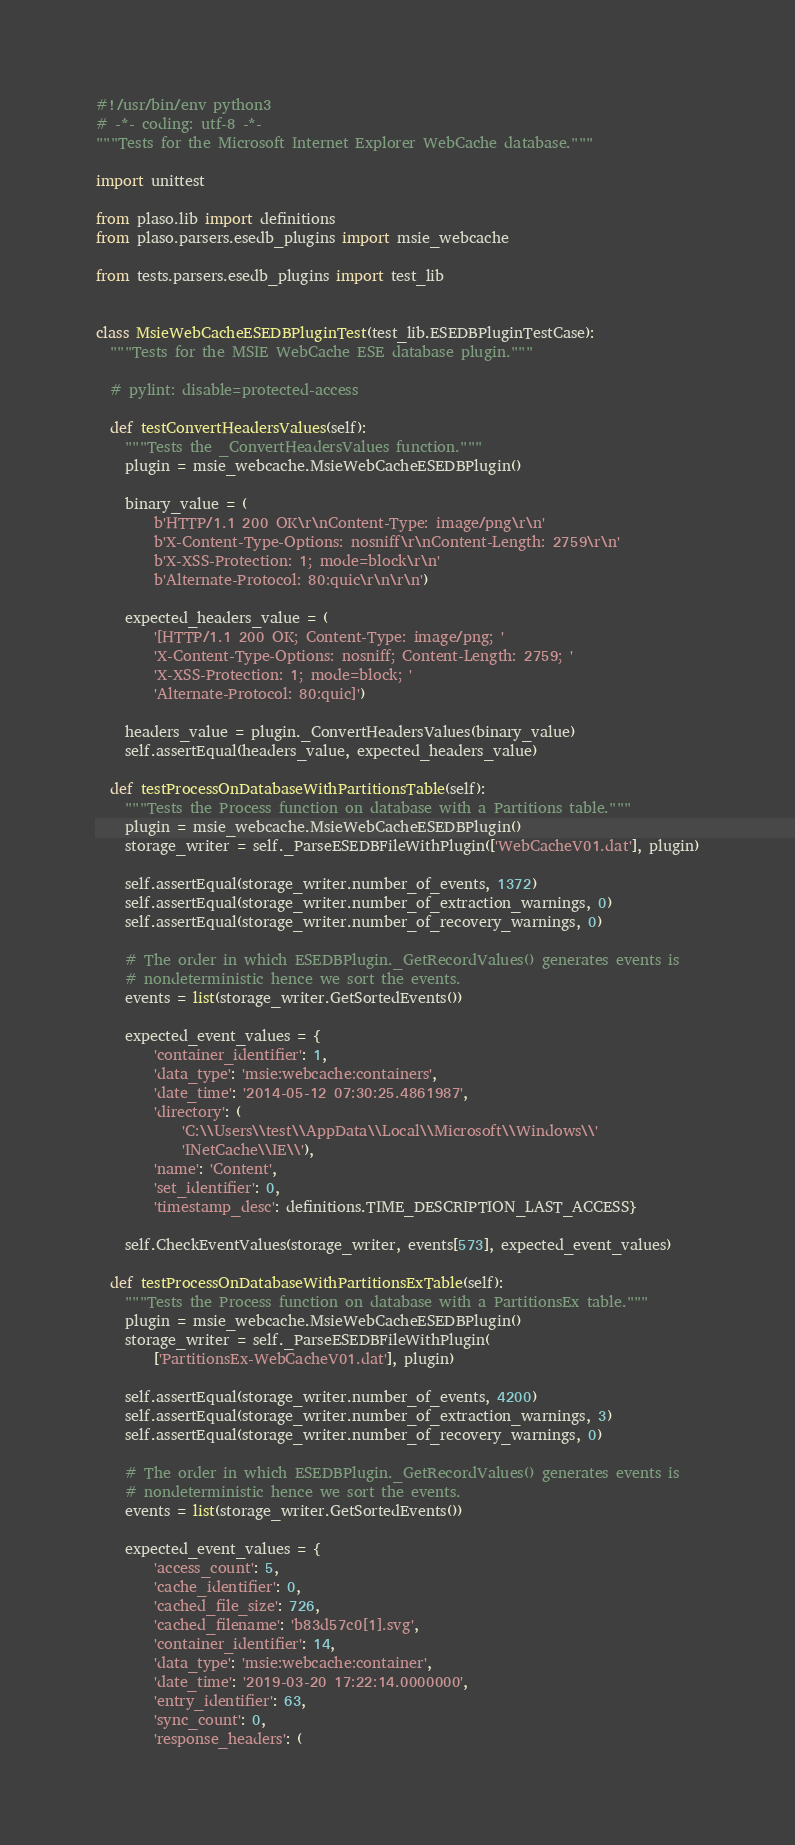<code> <loc_0><loc_0><loc_500><loc_500><_Python_>#!/usr/bin/env python3
# -*- coding: utf-8 -*-
"""Tests for the Microsoft Internet Explorer WebCache database."""

import unittest

from plaso.lib import definitions
from plaso.parsers.esedb_plugins import msie_webcache

from tests.parsers.esedb_plugins import test_lib


class MsieWebCacheESEDBPluginTest(test_lib.ESEDBPluginTestCase):
  """Tests for the MSIE WebCache ESE database plugin."""

  # pylint: disable=protected-access

  def testConvertHeadersValues(self):
    """Tests the _ConvertHeadersValues function."""
    plugin = msie_webcache.MsieWebCacheESEDBPlugin()

    binary_value = (
        b'HTTP/1.1 200 OK\r\nContent-Type: image/png\r\n'
        b'X-Content-Type-Options: nosniff\r\nContent-Length: 2759\r\n'
        b'X-XSS-Protection: 1; mode=block\r\n'
        b'Alternate-Protocol: 80:quic\r\n\r\n')

    expected_headers_value = (
        '[HTTP/1.1 200 OK; Content-Type: image/png; '
        'X-Content-Type-Options: nosniff; Content-Length: 2759; '
        'X-XSS-Protection: 1; mode=block; '
        'Alternate-Protocol: 80:quic]')

    headers_value = plugin._ConvertHeadersValues(binary_value)
    self.assertEqual(headers_value, expected_headers_value)

  def testProcessOnDatabaseWithPartitionsTable(self):
    """Tests the Process function on database with a Partitions table."""
    plugin = msie_webcache.MsieWebCacheESEDBPlugin()
    storage_writer = self._ParseESEDBFileWithPlugin(['WebCacheV01.dat'], plugin)

    self.assertEqual(storage_writer.number_of_events, 1372)
    self.assertEqual(storage_writer.number_of_extraction_warnings, 0)
    self.assertEqual(storage_writer.number_of_recovery_warnings, 0)

    # The order in which ESEDBPlugin._GetRecordValues() generates events is
    # nondeterministic hence we sort the events.
    events = list(storage_writer.GetSortedEvents())

    expected_event_values = {
        'container_identifier': 1,
        'data_type': 'msie:webcache:containers',
        'date_time': '2014-05-12 07:30:25.4861987',
        'directory': (
            'C:\\Users\\test\\AppData\\Local\\Microsoft\\Windows\\'
            'INetCache\\IE\\'),
        'name': 'Content',
        'set_identifier': 0,
        'timestamp_desc': definitions.TIME_DESCRIPTION_LAST_ACCESS}

    self.CheckEventValues(storage_writer, events[573], expected_event_values)

  def testProcessOnDatabaseWithPartitionsExTable(self):
    """Tests the Process function on database with a PartitionsEx table."""
    plugin = msie_webcache.MsieWebCacheESEDBPlugin()
    storage_writer = self._ParseESEDBFileWithPlugin(
        ['PartitionsEx-WebCacheV01.dat'], plugin)

    self.assertEqual(storage_writer.number_of_events, 4200)
    self.assertEqual(storage_writer.number_of_extraction_warnings, 3)
    self.assertEqual(storage_writer.number_of_recovery_warnings, 0)

    # The order in which ESEDBPlugin._GetRecordValues() generates events is
    # nondeterministic hence we sort the events.
    events = list(storage_writer.GetSortedEvents())

    expected_event_values = {
        'access_count': 5,
        'cache_identifier': 0,
        'cached_file_size': 726,
        'cached_filename': 'b83d57c0[1].svg',
        'container_identifier': 14,
        'data_type': 'msie:webcache:container',
        'date_time': '2019-03-20 17:22:14.0000000',
        'entry_identifier': 63,
        'sync_count': 0,
        'response_headers': (</code> 